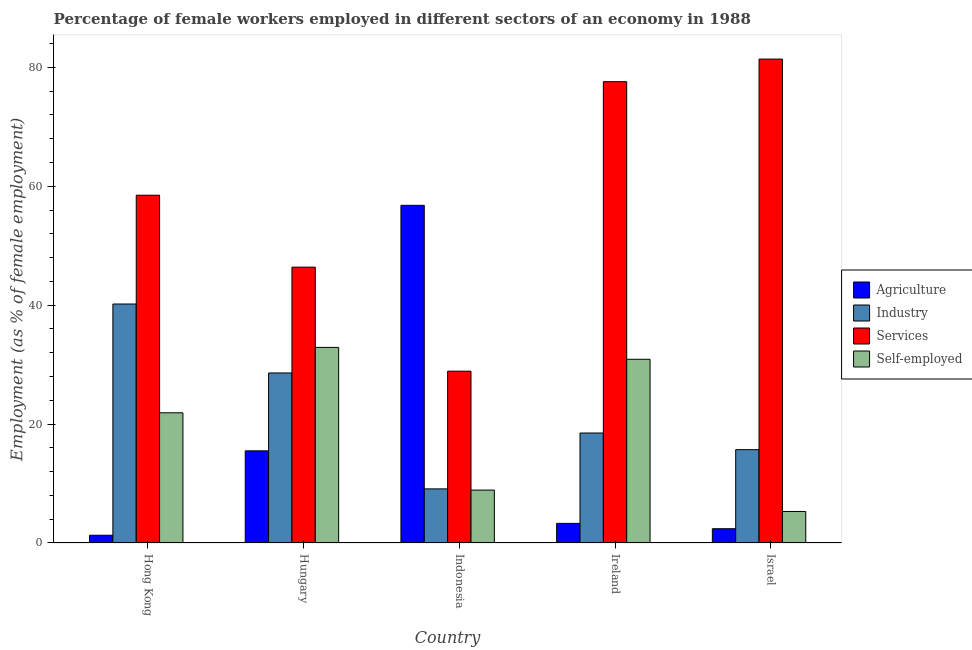How many groups of bars are there?
Offer a very short reply. 5. Are the number of bars per tick equal to the number of legend labels?
Your answer should be compact. Yes. How many bars are there on the 4th tick from the right?
Ensure brevity in your answer.  4. In how many cases, is the number of bars for a given country not equal to the number of legend labels?
Ensure brevity in your answer.  0. What is the percentage of self employed female workers in Hong Kong?
Give a very brief answer. 21.9. Across all countries, what is the maximum percentage of female workers in agriculture?
Your answer should be compact. 56.8. Across all countries, what is the minimum percentage of female workers in agriculture?
Provide a succinct answer. 1.3. In which country was the percentage of female workers in industry maximum?
Offer a very short reply. Hong Kong. In which country was the percentage of female workers in agriculture minimum?
Give a very brief answer. Hong Kong. What is the total percentage of female workers in agriculture in the graph?
Provide a short and direct response. 79.3. What is the difference between the percentage of self employed female workers in Hong Kong and that in Ireland?
Your response must be concise. -9. What is the difference between the percentage of female workers in services in Israel and the percentage of female workers in industry in Indonesia?
Your response must be concise. 72.3. What is the average percentage of female workers in agriculture per country?
Provide a succinct answer. 15.86. What is the difference between the percentage of self employed female workers and percentage of female workers in agriculture in Hungary?
Provide a succinct answer. 17.4. In how many countries, is the percentage of female workers in agriculture greater than 80 %?
Your answer should be compact. 0. What is the ratio of the percentage of female workers in industry in Hungary to that in Israel?
Your answer should be very brief. 1.82. Is the percentage of female workers in services in Hungary less than that in Ireland?
Your answer should be compact. Yes. What is the difference between the highest and the second highest percentage of female workers in agriculture?
Your response must be concise. 41.3. What is the difference between the highest and the lowest percentage of female workers in industry?
Your response must be concise. 31.1. Is the sum of the percentage of female workers in services in Hungary and Ireland greater than the maximum percentage of female workers in agriculture across all countries?
Your answer should be compact. Yes. Is it the case that in every country, the sum of the percentage of female workers in services and percentage of self employed female workers is greater than the sum of percentage of female workers in agriculture and percentage of female workers in industry?
Your answer should be compact. No. What does the 1st bar from the left in Israel represents?
Give a very brief answer. Agriculture. What does the 4th bar from the right in Ireland represents?
Offer a terse response. Agriculture. How many bars are there?
Provide a succinct answer. 20. Are all the bars in the graph horizontal?
Offer a very short reply. No. How many countries are there in the graph?
Offer a very short reply. 5. Are the values on the major ticks of Y-axis written in scientific E-notation?
Offer a very short reply. No. Does the graph contain any zero values?
Ensure brevity in your answer.  No. Does the graph contain grids?
Ensure brevity in your answer.  No. How many legend labels are there?
Offer a very short reply. 4. What is the title of the graph?
Give a very brief answer. Percentage of female workers employed in different sectors of an economy in 1988. What is the label or title of the Y-axis?
Your response must be concise. Employment (as % of female employment). What is the Employment (as % of female employment) in Agriculture in Hong Kong?
Your answer should be compact. 1.3. What is the Employment (as % of female employment) of Industry in Hong Kong?
Ensure brevity in your answer.  40.2. What is the Employment (as % of female employment) of Services in Hong Kong?
Your response must be concise. 58.5. What is the Employment (as % of female employment) of Self-employed in Hong Kong?
Offer a terse response. 21.9. What is the Employment (as % of female employment) in Industry in Hungary?
Make the answer very short. 28.6. What is the Employment (as % of female employment) in Services in Hungary?
Your answer should be compact. 46.4. What is the Employment (as % of female employment) of Self-employed in Hungary?
Provide a succinct answer. 32.9. What is the Employment (as % of female employment) in Agriculture in Indonesia?
Your response must be concise. 56.8. What is the Employment (as % of female employment) of Industry in Indonesia?
Provide a succinct answer. 9.1. What is the Employment (as % of female employment) in Services in Indonesia?
Your answer should be compact. 28.9. What is the Employment (as % of female employment) of Self-employed in Indonesia?
Your answer should be compact. 8.9. What is the Employment (as % of female employment) of Agriculture in Ireland?
Offer a terse response. 3.3. What is the Employment (as % of female employment) of Services in Ireland?
Offer a terse response. 77.6. What is the Employment (as % of female employment) in Self-employed in Ireland?
Your response must be concise. 30.9. What is the Employment (as % of female employment) in Agriculture in Israel?
Provide a succinct answer. 2.4. What is the Employment (as % of female employment) in Industry in Israel?
Your response must be concise. 15.7. What is the Employment (as % of female employment) in Services in Israel?
Your response must be concise. 81.4. What is the Employment (as % of female employment) of Self-employed in Israel?
Offer a terse response. 5.3. Across all countries, what is the maximum Employment (as % of female employment) in Agriculture?
Keep it short and to the point. 56.8. Across all countries, what is the maximum Employment (as % of female employment) of Industry?
Your answer should be compact. 40.2. Across all countries, what is the maximum Employment (as % of female employment) of Services?
Provide a succinct answer. 81.4. Across all countries, what is the maximum Employment (as % of female employment) in Self-employed?
Give a very brief answer. 32.9. Across all countries, what is the minimum Employment (as % of female employment) of Agriculture?
Your answer should be very brief. 1.3. Across all countries, what is the minimum Employment (as % of female employment) in Industry?
Ensure brevity in your answer.  9.1. Across all countries, what is the minimum Employment (as % of female employment) in Services?
Your answer should be compact. 28.9. Across all countries, what is the minimum Employment (as % of female employment) in Self-employed?
Ensure brevity in your answer.  5.3. What is the total Employment (as % of female employment) in Agriculture in the graph?
Your answer should be compact. 79.3. What is the total Employment (as % of female employment) of Industry in the graph?
Give a very brief answer. 112.1. What is the total Employment (as % of female employment) in Services in the graph?
Provide a short and direct response. 292.8. What is the total Employment (as % of female employment) of Self-employed in the graph?
Offer a terse response. 99.9. What is the difference between the Employment (as % of female employment) in Industry in Hong Kong and that in Hungary?
Keep it short and to the point. 11.6. What is the difference between the Employment (as % of female employment) in Self-employed in Hong Kong and that in Hungary?
Your answer should be very brief. -11. What is the difference between the Employment (as % of female employment) of Agriculture in Hong Kong and that in Indonesia?
Offer a terse response. -55.5. What is the difference between the Employment (as % of female employment) in Industry in Hong Kong and that in Indonesia?
Keep it short and to the point. 31.1. What is the difference between the Employment (as % of female employment) of Services in Hong Kong and that in Indonesia?
Provide a succinct answer. 29.6. What is the difference between the Employment (as % of female employment) of Industry in Hong Kong and that in Ireland?
Your answer should be compact. 21.7. What is the difference between the Employment (as % of female employment) in Services in Hong Kong and that in Ireland?
Provide a short and direct response. -19.1. What is the difference between the Employment (as % of female employment) in Industry in Hong Kong and that in Israel?
Your response must be concise. 24.5. What is the difference between the Employment (as % of female employment) of Services in Hong Kong and that in Israel?
Provide a short and direct response. -22.9. What is the difference between the Employment (as % of female employment) of Agriculture in Hungary and that in Indonesia?
Your answer should be compact. -41.3. What is the difference between the Employment (as % of female employment) of Industry in Hungary and that in Indonesia?
Your answer should be very brief. 19.5. What is the difference between the Employment (as % of female employment) of Services in Hungary and that in Indonesia?
Provide a succinct answer. 17.5. What is the difference between the Employment (as % of female employment) of Services in Hungary and that in Ireland?
Provide a short and direct response. -31.2. What is the difference between the Employment (as % of female employment) in Agriculture in Hungary and that in Israel?
Make the answer very short. 13.1. What is the difference between the Employment (as % of female employment) of Industry in Hungary and that in Israel?
Your response must be concise. 12.9. What is the difference between the Employment (as % of female employment) of Services in Hungary and that in Israel?
Ensure brevity in your answer.  -35. What is the difference between the Employment (as % of female employment) of Self-employed in Hungary and that in Israel?
Make the answer very short. 27.6. What is the difference between the Employment (as % of female employment) of Agriculture in Indonesia and that in Ireland?
Keep it short and to the point. 53.5. What is the difference between the Employment (as % of female employment) in Industry in Indonesia and that in Ireland?
Provide a succinct answer. -9.4. What is the difference between the Employment (as % of female employment) in Services in Indonesia and that in Ireland?
Make the answer very short. -48.7. What is the difference between the Employment (as % of female employment) in Agriculture in Indonesia and that in Israel?
Keep it short and to the point. 54.4. What is the difference between the Employment (as % of female employment) of Industry in Indonesia and that in Israel?
Offer a very short reply. -6.6. What is the difference between the Employment (as % of female employment) in Services in Indonesia and that in Israel?
Offer a terse response. -52.5. What is the difference between the Employment (as % of female employment) of Self-employed in Indonesia and that in Israel?
Make the answer very short. 3.6. What is the difference between the Employment (as % of female employment) in Agriculture in Ireland and that in Israel?
Keep it short and to the point. 0.9. What is the difference between the Employment (as % of female employment) of Self-employed in Ireland and that in Israel?
Give a very brief answer. 25.6. What is the difference between the Employment (as % of female employment) in Agriculture in Hong Kong and the Employment (as % of female employment) in Industry in Hungary?
Offer a terse response. -27.3. What is the difference between the Employment (as % of female employment) of Agriculture in Hong Kong and the Employment (as % of female employment) of Services in Hungary?
Provide a short and direct response. -45.1. What is the difference between the Employment (as % of female employment) of Agriculture in Hong Kong and the Employment (as % of female employment) of Self-employed in Hungary?
Provide a short and direct response. -31.6. What is the difference between the Employment (as % of female employment) of Services in Hong Kong and the Employment (as % of female employment) of Self-employed in Hungary?
Offer a terse response. 25.6. What is the difference between the Employment (as % of female employment) of Agriculture in Hong Kong and the Employment (as % of female employment) of Services in Indonesia?
Provide a short and direct response. -27.6. What is the difference between the Employment (as % of female employment) in Industry in Hong Kong and the Employment (as % of female employment) in Self-employed in Indonesia?
Your answer should be compact. 31.3. What is the difference between the Employment (as % of female employment) in Services in Hong Kong and the Employment (as % of female employment) in Self-employed in Indonesia?
Offer a terse response. 49.6. What is the difference between the Employment (as % of female employment) of Agriculture in Hong Kong and the Employment (as % of female employment) of Industry in Ireland?
Ensure brevity in your answer.  -17.2. What is the difference between the Employment (as % of female employment) of Agriculture in Hong Kong and the Employment (as % of female employment) of Services in Ireland?
Your answer should be very brief. -76.3. What is the difference between the Employment (as % of female employment) of Agriculture in Hong Kong and the Employment (as % of female employment) of Self-employed in Ireland?
Your response must be concise. -29.6. What is the difference between the Employment (as % of female employment) in Industry in Hong Kong and the Employment (as % of female employment) in Services in Ireland?
Your answer should be compact. -37.4. What is the difference between the Employment (as % of female employment) of Industry in Hong Kong and the Employment (as % of female employment) of Self-employed in Ireland?
Your response must be concise. 9.3. What is the difference between the Employment (as % of female employment) of Services in Hong Kong and the Employment (as % of female employment) of Self-employed in Ireland?
Your answer should be compact. 27.6. What is the difference between the Employment (as % of female employment) in Agriculture in Hong Kong and the Employment (as % of female employment) in Industry in Israel?
Your answer should be very brief. -14.4. What is the difference between the Employment (as % of female employment) in Agriculture in Hong Kong and the Employment (as % of female employment) in Services in Israel?
Your answer should be compact. -80.1. What is the difference between the Employment (as % of female employment) of Agriculture in Hong Kong and the Employment (as % of female employment) of Self-employed in Israel?
Your response must be concise. -4. What is the difference between the Employment (as % of female employment) in Industry in Hong Kong and the Employment (as % of female employment) in Services in Israel?
Provide a short and direct response. -41.2. What is the difference between the Employment (as % of female employment) in Industry in Hong Kong and the Employment (as % of female employment) in Self-employed in Israel?
Offer a terse response. 34.9. What is the difference between the Employment (as % of female employment) of Services in Hong Kong and the Employment (as % of female employment) of Self-employed in Israel?
Make the answer very short. 53.2. What is the difference between the Employment (as % of female employment) of Agriculture in Hungary and the Employment (as % of female employment) of Self-employed in Indonesia?
Make the answer very short. 6.6. What is the difference between the Employment (as % of female employment) of Industry in Hungary and the Employment (as % of female employment) of Self-employed in Indonesia?
Ensure brevity in your answer.  19.7. What is the difference between the Employment (as % of female employment) in Services in Hungary and the Employment (as % of female employment) in Self-employed in Indonesia?
Keep it short and to the point. 37.5. What is the difference between the Employment (as % of female employment) in Agriculture in Hungary and the Employment (as % of female employment) in Industry in Ireland?
Keep it short and to the point. -3. What is the difference between the Employment (as % of female employment) of Agriculture in Hungary and the Employment (as % of female employment) of Services in Ireland?
Keep it short and to the point. -62.1. What is the difference between the Employment (as % of female employment) of Agriculture in Hungary and the Employment (as % of female employment) of Self-employed in Ireland?
Your response must be concise. -15.4. What is the difference between the Employment (as % of female employment) in Industry in Hungary and the Employment (as % of female employment) in Services in Ireland?
Keep it short and to the point. -49. What is the difference between the Employment (as % of female employment) of Industry in Hungary and the Employment (as % of female employment) of Self-employed in Ireland?
Give a very brief answer. -2.3. What is the difference between the Employment (as % of female employment) in Agriculture in Hungary and the Employment (as % of female employment) in Industry in Israel?
Provide a short and direct response. -0.2. What is the difference between the Employment (as % of female employment) of Agriculture in Hungary and the Employment (as % of female employment) of Services in Israel?
Provide a short and direct response. -65.9. What is the difference between the Employment (as % of female employment) in Agriculture in Hungary and the Employment (as % of female employment) in Self-employed in Israel?
Offer a terse response. 10.2. What is the difference between the Employment (as % of female employment) of Industry in Hungary and the Employment (as % of female employment) of Services in Israel?
Give a very brief answer. -52.8. What is the difference between the Employment (as % of female employment) in Industry in Hungary and the Employment (as % of female employment) in Self-employed in Israel?
Ensure brevity in your answer.  23.3. What is the difference between the Employment (as % of female employment) in Services in Hungary and the Employment (as % of female employment) in Self-employed in Israel?
Make the answer very short. 41.1. What is the difference between the Employment (as % of female employment) of Agriculture in Indonesia and the Employment (as % of female employment) of Industry in Ireland?
Provide a succinct answer. 38.3. What is the difference between the Employment (as % of female employment) in Agriculture in Indonesia and the Employment (as % of female employment) in Services in Ireland?
Your answer should be compact. -20.8. What is the difference between the Employment (as % of female employment) of Agriculture in Indonesia and the Employment (as % of female employment) of Self-employed in Ireland?
Give a very brief answer. 25.9. What is the difference between the Employment (as % of female employment) of Industry in Indonesia and the Employment (as % of female employment) of Services in Ireland?
Your answer should be very brief. -68.5. What is the difference between the Employment (as % of female employment) in Industry in Indonesia and the Employment (as % of female employment) in Self-employed in Ireland?
Offer a very short reply. -21.8. What is the difference between the Employment (as % of female employment) of Agriculture in Indonesia and the Employment (as % of female employment) of Industry in Israel?
Offer a terse response. 41.1. What is the difference between the Employment (as % of female employment) in Agriculture in Indonesia and the Employment (as % of female employment) in Services in Israel?
Give a very brief answer. -24.6. What is the difference between the Employment (as % of female employment) of Agriculture in Indonesia and the Employment (as % of female employment) of Self-employed in Israel?
Provide a short and direct response. 51.5. What is the difference between the Employment (as % of female employment) of Industry in Indonesia and the Employment (as % of female employment) of Services in Israel?
Give a very brief answer. -72.3. What is the difference between the Employment (as % of female employment) of Industry in Indonesia and the Employment (as % of female employment) of Self-employed in Israel?
Provide a short and direct response. 3.8. What is the difference between the Employment (as % of female employment) of Services in Indonesia and the Employment (as % of female employment) of Self-employed in Israel?
Give a very brief answer. 23.6. What is the difference between the Employment (as % of female employment) in Agriculture in Ireland and the Employment (as % of female employment) in Industry in Israel?
Offer a terse response. -12.4. What is the difference between the Employment (as % of female employment) of Agriculture in Ireland and the Employment (as % of female employment) of Services in Israel?
Provide a short and direct response. -78.1. What is the difference between the Employment (as % of female employment) in Industry in Ireland and the Employment (as % of female employment) in Services in Israel?
Provide a short and direct response. -62.9. What is the difference between the Employment (as % of female employment) in Industry in Ireland and the Employment (as % of female employment) in Self-employed in Israel?
Your response must be concise. 13.2. What is the difference between the Employment (as % of female employment) in Services in Ireland and the Employment (as % of female employment) in Self-employed in Israel?
Provide a short and direct response. 72.3. What is the average Employment (as % of female employment) in Agriculture per country?
Provide a succinct answer. 15.86. What is the average Employment (as % of female employment) of Industry per country?
Give a very brief answer. 22.42. What is the average Employment (as % of female employment) in Services per country?
Keep it short and to the point. 58.56. What is the average Employment (as % of female employment) of Self-employed per country?
Ensure brevity in your answer.  19.98. What is the difference between the Employment (as % of female employment) in Agriculture and Employment (as % of female employment) in Industry in Hong Kong?
Ensure brevity in your answer.  -38.9. What is the difference between the Employment (as % of female employment) of Agriculture and Employment (as % of female employment) of Services in Hong Kong?
Your answer should be very brief. -57.2. What is the difference between the Employment (as % of female employment) of Agriculture and Employment (as % of female employment) of Self-employed in Hong Kong?
Provide a succinct answer. -20.6. What is the difference between the Employment (as % of female employment) in Industry and Employment (as % of female employment) in Services in Hong Kong?
Keep it short and to the point. -18.3. What is the difference between the Employment (as % of female employment) of Services and Employment (as % of female employment) of Self-employed in Hong Kong?
Keep it short and to the point. 36.6. What is the difference between the Employment (as % of female employment) of Agriculture and Employment (as % of female employment) of Services in Hungary?
Provide a short and direct response. -30.9. What is the difference between the Employment (as % of female employment) in Agriculture and Employment (as % of female employment) in Self-employed in Hungary?
Your answer should be compact. -17.4. What is the difference between the Employment (as % of female employment) of Industry and Employment (as % of female employment) of Services in Hungary?
Offer a very short reply. -17.8. What is the difference between the Employment (as % of female employment) of Industry and Employment (as % of female employment) of Self-employed in Hungary?
Offer a very short reply. -4.3. What is the difference between the Employment (as % of female employment) of Services and Employment (as % of female employment) of Self-employed in Hungary?
Provide a short and direct response. 13.5. What is the difference between the Employment (as % of female employment) in Agriculture and Employment (as % of female employment) in Industry in Indonesia?
Ensure brevity in your answer.  47.7. What is the difference between the Employment (as % of female employment) in Agriculture and Employment (as % of female employment) in Services in Indonesia?
Your answer should be compact. 27.9. What is the difference between the Employment (as % of female employment) of Agriculture and Employment (as % of female employment) of Self-employed in Indonesia?
Make the answer very short. 47.9. What is the difference between the Employment (as % of female employment) in Industry and Employment (as % of female employment) in Services in Indonesia?
Ensure brevity in your answer.  -19.8. What is the difference between the Employment (as % of female employment) in Agriculture and Employment (as % of female employment) in Industry in Ireland?
Offer a terse response. -15.2. What is the difference between the Employment (as % of female employment) of Agriculture and Employment (as % of female employment) of Services in Ireland?
Your answer should be very brief. -74.3. What is the difference between the Employment (as % of female employment) in Agriculture and Employment (as % of female employment) in Self-employed in Ireland?
Your answer should be compact. -27.6. What is the difference between the Employment (as % of female employment) of Industry and Employment (as % of female employment) of Services in Ireland?
Offer a terse response. -59.1. What is the difference between the Employment (as % of female employment) in Industry and Employment (as % of female employment) in Self-employed in Ireland?
Your response must be concise. -12.4. What is the difference between the Employment (as % of female employment) of Services and Employment (as % of female employment) of Self-employed in Ireland?
Your response must be concise. 46.7. What is the difference between the Employment (as % of female employment) in Agriculture and Employment (as % of female employment) in Industry in Israel?
Make the answer very short. -13.3. What is the difference between the Employment (as % of female employment) in Agriculture and Employment (as % of female employment) in Services in Israel?
Provide a short and direct response. -79. What is the difference between the Employment (as % of female employment) of Agriculture and Employment (as % of female employment) of Self-employed in Israel?
Your answer should be very brief. -2.9. What is the difference between the Employment (as % of female employment) of Industry and Employment (as % of female employment) of Services in Israel?
Your response must be concise. -65.7. What is the difference between the Employment (as % of female employment) of Industry and Employment (as % of female employment) of Self-employed in Israel?
Your answer should be very brief. 10.4. What is the difference between the Employment (as % of female employment) in Services and Employment (as % of female employment) in Self-employed in Israel?
Make the answer very short. 76.1. What is the ratio of the Employment (as % of female employment) of Agriculture in Hong Kong to that in Hungary?
Make the answer very short. 0.08. What is the ratio of the Employment (as % of female employment) in Industry in Hong Kong to that in Hungary?
Your answer should be compact. 1.41. What is the ratio of the Employment (as % of female employment) in Services in Hong Kong to that in Hungary?
Your answer should be compact. 1.26. What is the ratio of the Employment (as % of female employment) of Self-employed in Hong Kong to that in Hungary?
Give a very brief answer. 0.67. What is the ratio of the Employment (as % of female employment) of Agriculture in Hong Kong to that in Indonesia?
Offer a very short reply. 0.02. What is the ratio of the Employment (as % of female employment) in Industry in Hong Kong to that in Indonesia?
Give a very brief answer. 4.42. What is the ratio of the Employment (as % of female employment) in Services in Hong Kong to that in Indonesia?
Offer a very short reply. 2.02. What is the ratio of the Employment (as % of female employment) of Self-employed in Hong Kong to that in Indonesia?
Give a very brief answer. 2.46. What is the ratio of the Employment (as % of female employment) in Agriculture in Hong Kong to that in Ireland?
Your answer should be compact. 0.39. What is the ratio of the Employment (as % of female employment) of Industry in Hong Kong to that in Ireland?
Make the answer very short. 2.17. What is the ratio of the Employment (as % of female employment) of Services in Hong Kong to that in Ireland?
Make the answer very short. 0.75. What is the ratio of the Employment (as % of female employment) of Self-employed in Hong Kong to that in Ireland?
Your answer should be compact. 0.71. What is the ratio of the Employment (as % of female employment) of Agriculture in Hong Kong to that in Israel?
Provide a short and direct response. 0.54. What is the ratio of the Employment (as % of female employment) of Industry in Hong Kong to that in Israel?
Keep it short and to the point. 2.56. What is the ratio of the Employment (as % of female employment) of Services in Hong Kong to that in Israel?
Offer a very short reply. 0.72. What is the ratio of the Employment (as % of female employment) in Self-employed in Hong Kong to that in Israel?
Make the answer very short. 4.13. What is the ratio of the Employment (as % of female employment) in Agriculture in Hungary to that in Indonesia?
Ensure brevity in your answer.  0.27. What is the ratio of the Employment (as % of female employment) in Industry in Hungary to that in Indonesia?
Provide a succinct answer. 3.14. What is the ratio of the Employment (as % of female employment) in Services in Hungary to that in Indonesia?
Make the answer very short. 1.61. What is the ratio of the Employment (as % of female employment) of Self-employed in Hungary to that in Indonesia?
Give a very brief answer. 3.7. What is the ratio of the Employment (as % of female employment) of Agriculture in Hungary to that in Ireland?
Your response must be concise. 4.7. What is the ratio of the Employment (as % of female employment) of Industry in Hungary to that in Ireland?
Give a very brief answer. 1.55. What is the ratio of the Employment (as % of female employment) of Services in Hungary to that in Ireland?
Offer a very short reply. 0.6. What is the ratio of the Employment (as % of female employment) in Self-employed in Hungary to that in Ireland?
Provide a succinct answer. 1.06. What is the ratio of the Employment (as % of female employment) of Agriculture in Hungary to that in Israel?
Keep it short and to the point. 6.46. What is the ratio of the Employment (as % of female employment) of Industry in Hungary to that in Israel?
Ensure brevity in your answer.  1.82. What is the ratio of the Employment (as % of female employment) of Services in Hungary to that in Israel?
Make the answer very short. 0.57. What is the ratio of the Employment (as % of female employment) in Self-employed in Hungary to that in Israel?
Ensure brevity in your answer.  6.21. What is the ratio of the Employment (as % of female employment) in Agriculture in Indonesia to that in Ireland?
Provide a short and direct response. 17.21. What is the ratio of the Employment (as % of female employment) of Industry in Indonesia to that in Ireland?
Make the answer very short. 0.49. What is the ratio of the Employment (as % of female employment) of Services in Indonesia to that in Ireland?
Offer a very short reply. 0.37. What is the ratio of the Employment (as % of female employment) in Self-employed in Indonesia to that in Ireland?
Offer a very short reply. 0.29. What is the ratio of the Employment (as % of female employment) in Agriculture in Indonesia to that in Israel?
Offer a very short reply. 23.67. What is the ratio of the Employment (as % of female employment) in Industry in Indonesia to that in Israel?
Make the answer very short. 0.58. What is the ratio of the Employment (as % of female employment) of Services in Indonesia to that in Israel?
Provide a short and direct response. 0.35. What is the ratio of the Employment (as % of female employment) of Self-employed in Indonesia to that in Israel?
Provide a succinct answer. 1.68. What is the ratio of the Employment (as % of female employment) in Agriculture in Ireland to that in Israel?
Keep it short and to the point. 1.38. What is the ratio of the Employment (as % of female employment) of Industry in Ireland to that in Israel?
Provide a succinct answer. 1.18. What is the ratio of the Employment (as % of female employment) in Services in Ireland to that in Israel?
Ensure brevity in your answer.  0.95. What is the ratio of the Employment (as % of female employment) of Self-employed in Ireland to that in Israel?
Provide a short and direct response. 5.83. What is the difference between the highest and the second highest Employment (as % of female employment) of Agriculture?
Ensure brevity in your answer.  41.3. What is the difference between the highest and the lowest Employment (as % of female employment) of Agriculture?
Provide a succinct answer. 55.5. What is the difference between the highest and the lowest Employment (as % of female employment) in Industry?
Your answer should be very brief. 31.1. What is the difference between the highest and the lowest Employment (as % of female employment) of Services?
Ensure brevity in your answer.  52.5. What is the difference between the highest and the lowest Employment (as % of female employment) in Self-employed?
Offer a very short reply. 27.6. 